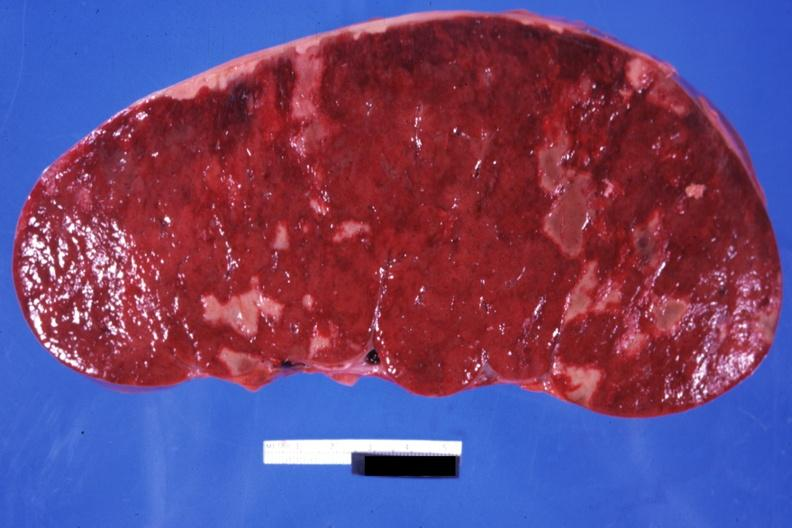s bicornate uterus easily seen?
Answer the question using a single word or phrase. No 